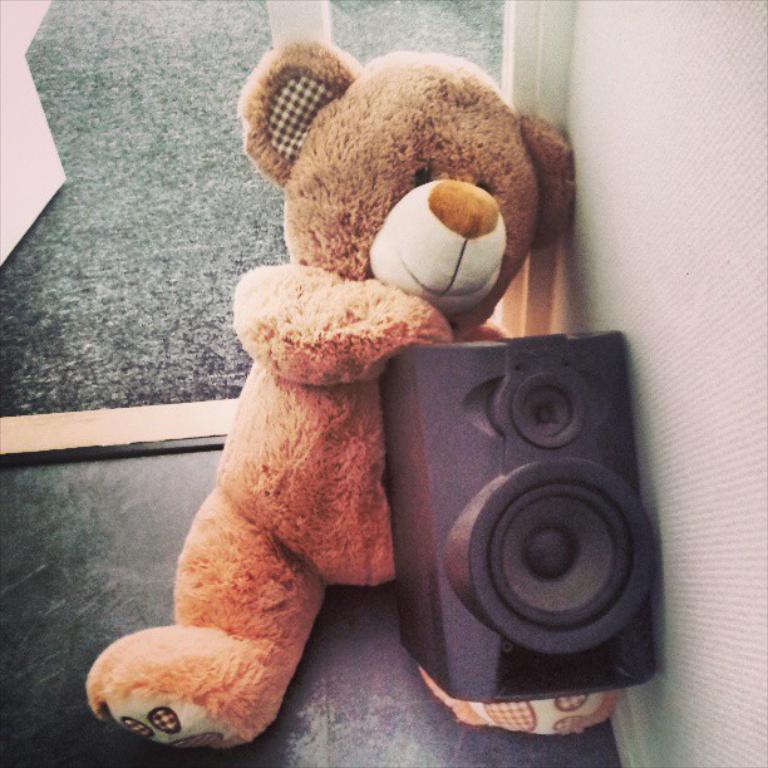In one or two sentences, can you explain what this image depicts? In this image we can see a teddy bear, speaker. At the bottom of the image there is floor. To the right side of the image there is wall. 